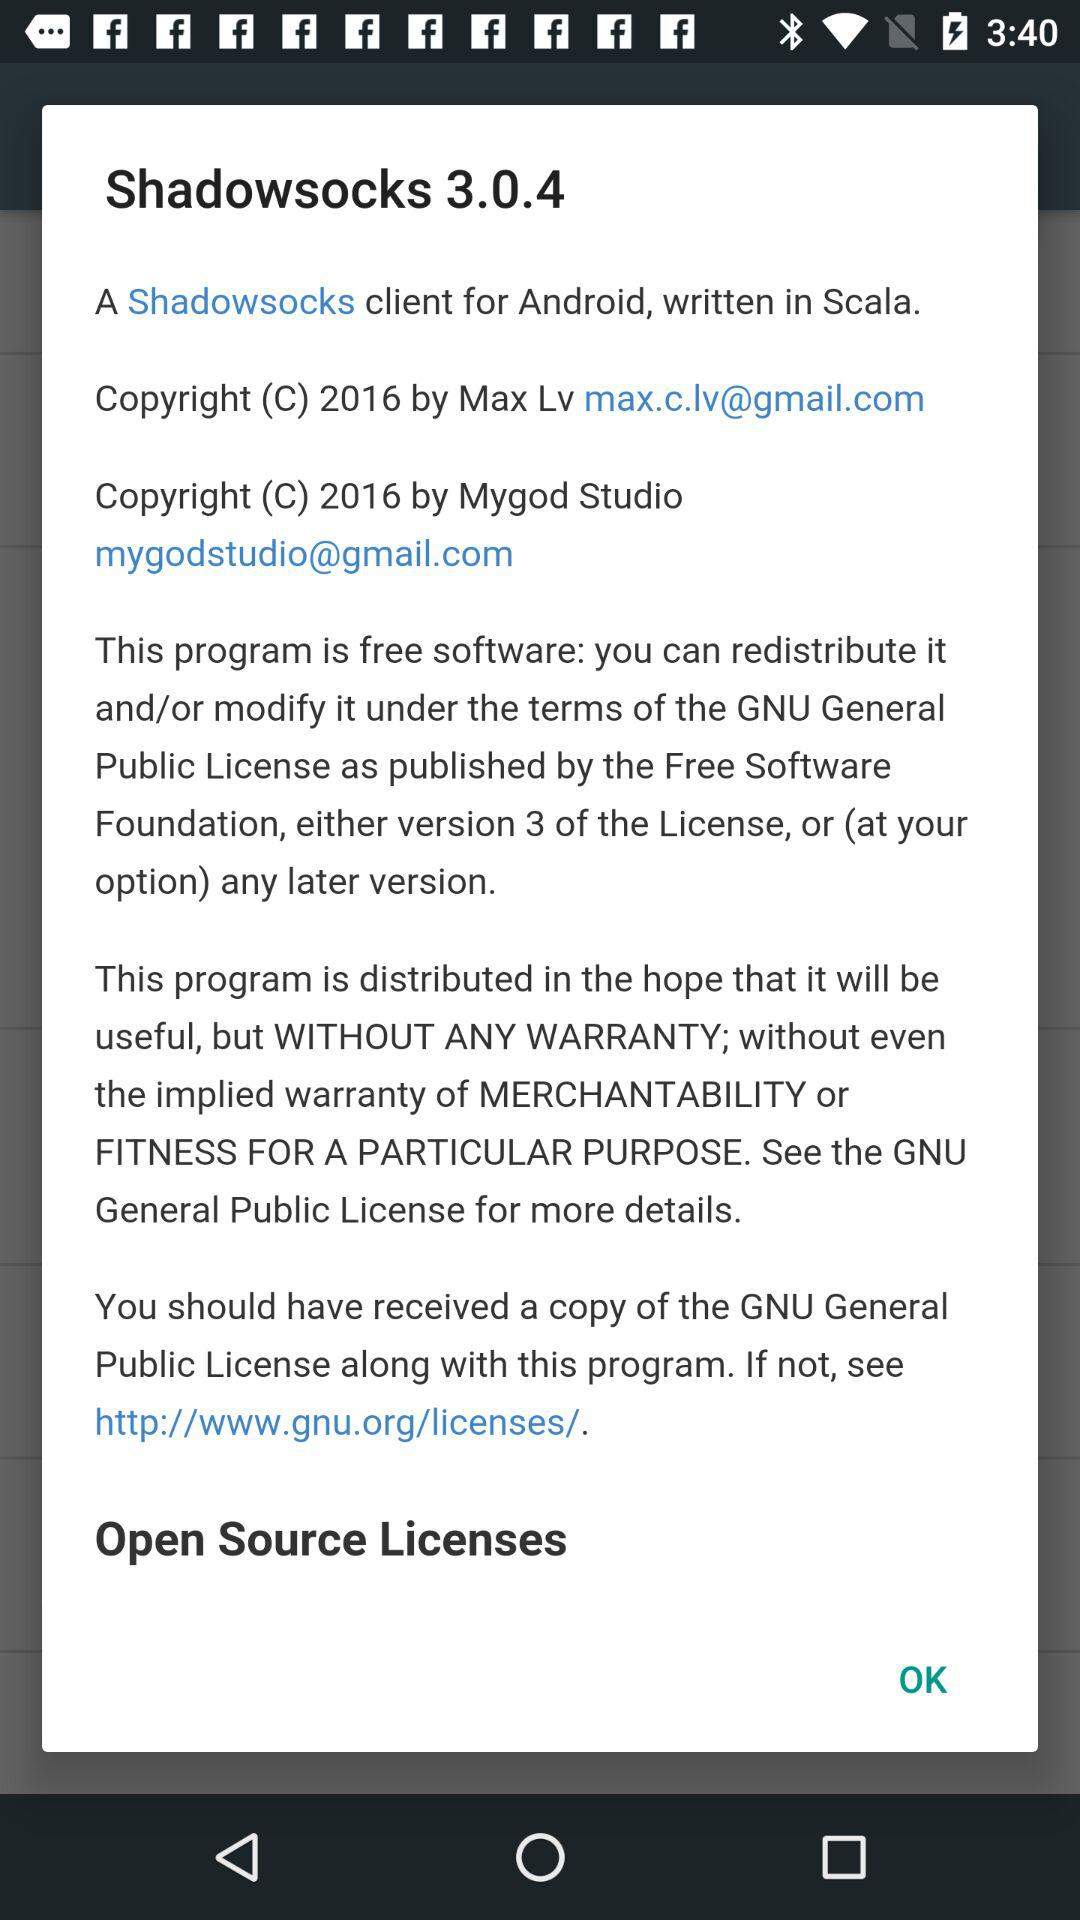How many copyright notices are there?
Answer the question using a single word or phrase. 2 